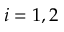<formula> <loc_0><loc_0><loc_500><loc_500>i = 1 , 2</formula> 